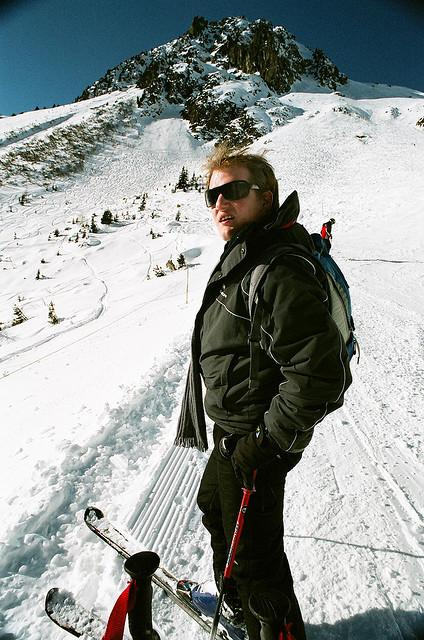What look does the man have on his face?

Choices:
A) sadness
B) disgust
C) love
D) joy disgust 